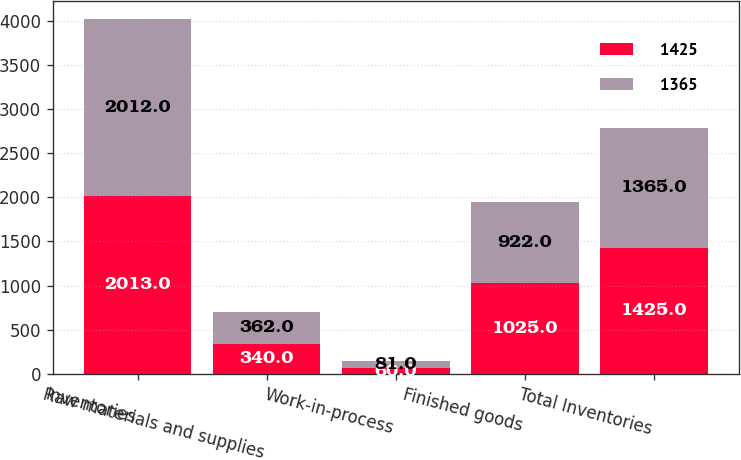Convert chart. <chart><loc_0><loc_0><loc_500><loc_500><stacked_bar_chart><ecel><fcel>Inventories<fcel>Raw materials and supplies<fcel>Work-in-process<fcel>Finished goods<fcel>Total Inventories<nl><fcel>1425<fcel>2013<fcel>340<fcel>60<fcel>1025<fcel>1425<nl><fcel>1365<fcel>2012<fcel>362<fcel>81<fcel>922<fcel>1365<nl></chart> 